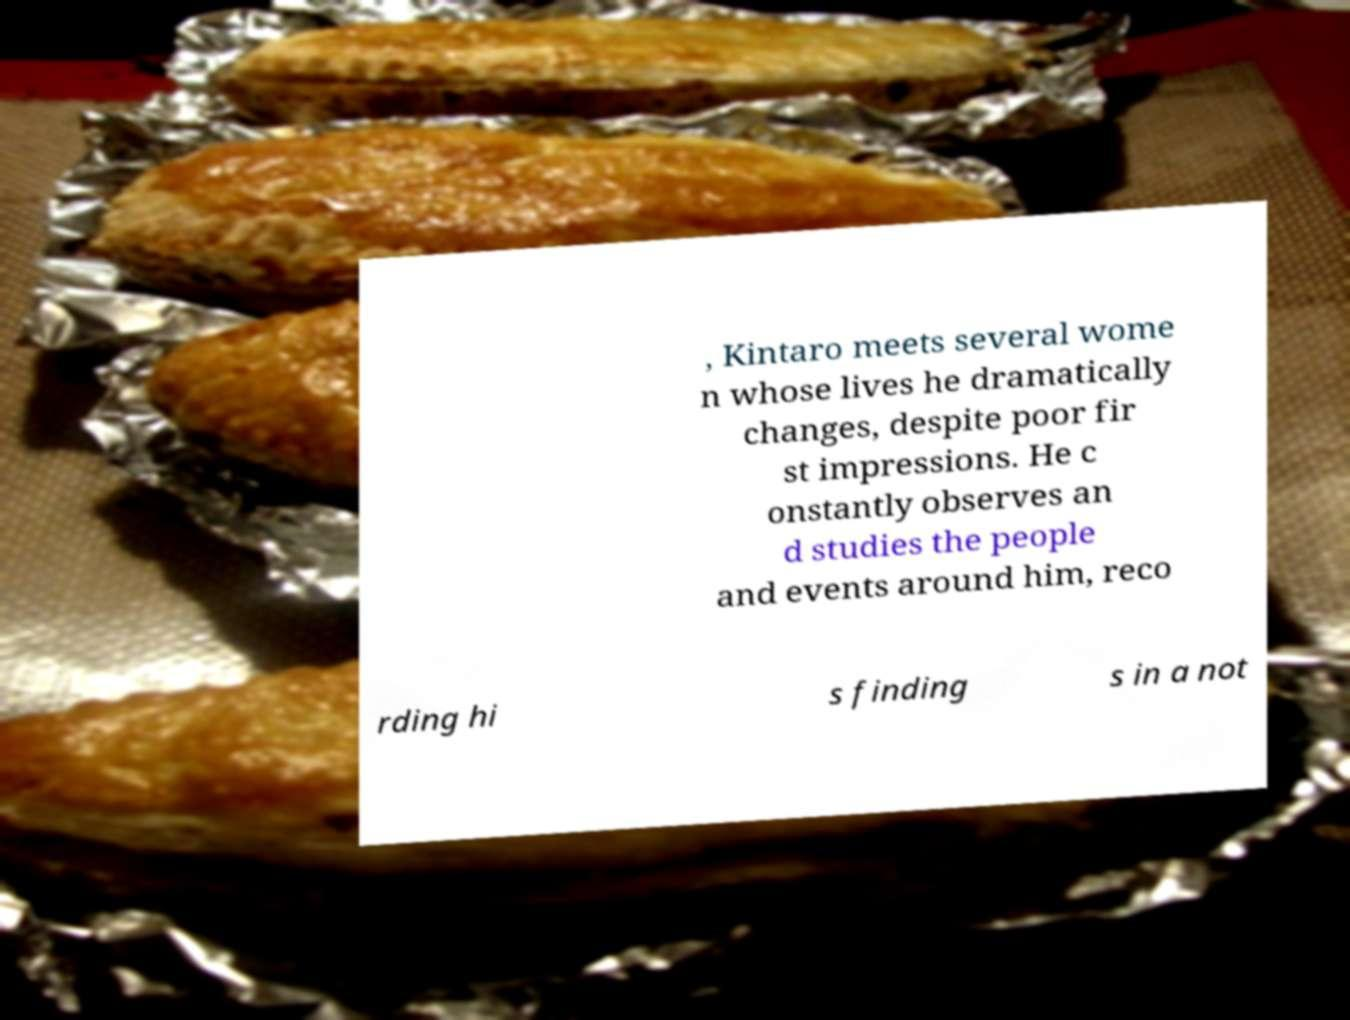There's text embedded in this image that I need extracted. Can you transcribe it verbatim? , Kintaro meets several wome n whose lives he dramatically changes, despite poor fir st impressions. He c onstantly observes an d studies the people and events around him, reco rding hi s finding s in a not 